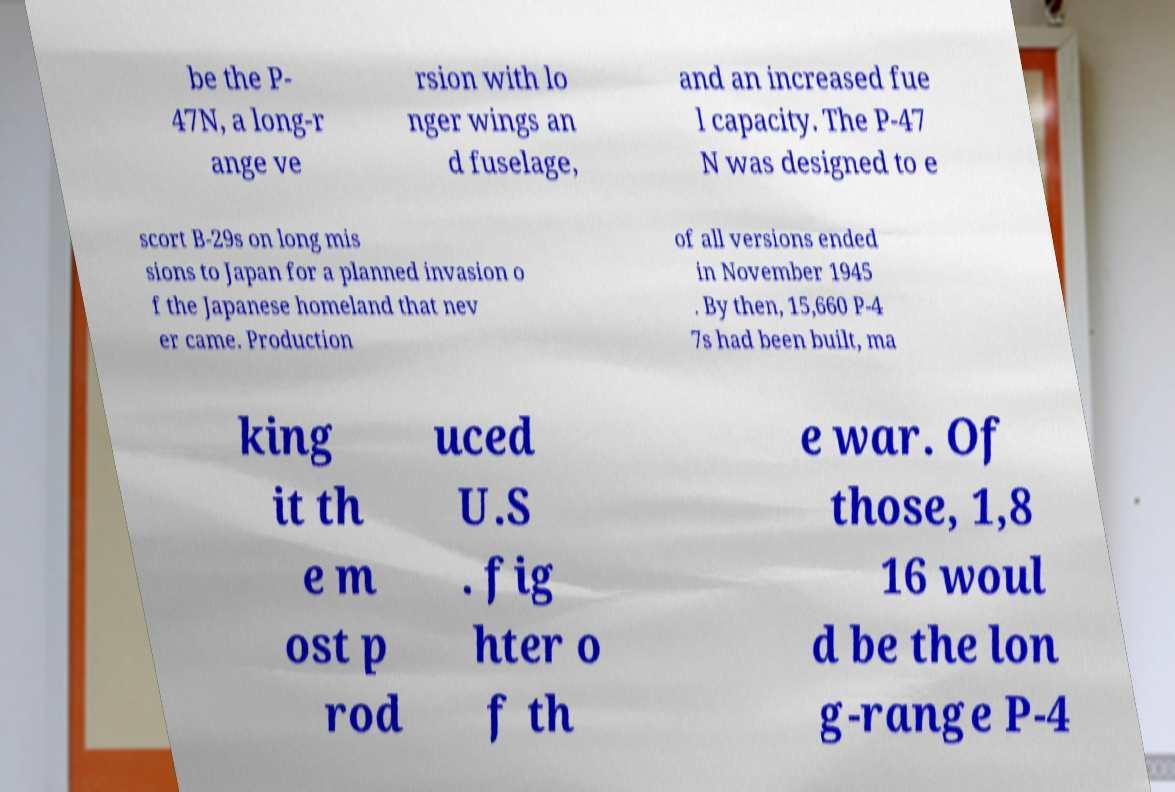Could you extract and type out the text from this image? be the P- 47N, a long-r ange ve rsion with lo nger wings an d fuselage, and an increased fue l capacity. The P-47 N was designed to e scort B-29s on long mis sions to Japan for a planned invasion o f the Japanese homeland that nev er came. Production of all versions ended in November 1945 . By then, 15,660 P-4 7s had been built, ma king it th e m ost p rod uced U.S . fig hter o f th e war. Of those, 1,8 16 woul d be the lon g-range P-4 